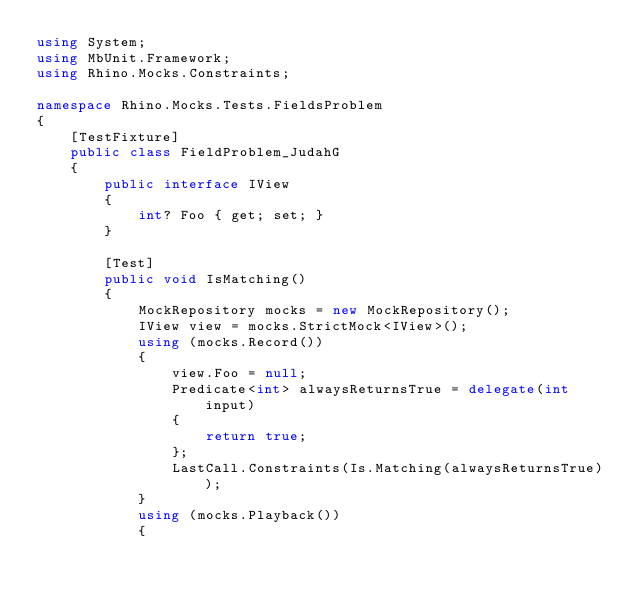<code> <loc_0><loc_0><loc_500><loc_500><_C#_>using System;
using MbUnit.Framework;
using Rhino.Mocks.Constraints;

namespace Rhino.Mocks.Tests.FieldsProblem
{
	[TestFixture]
	public class FieldProblem_JudahG
	{
		public interface IView
		{
			int? Foo { get; set; }
		}

		[Test]
		public void IsMatching()
		{
			MockRepository mocks = new MockRepository();
			IView view = mocks.StrictMock<IView>();
			using (mocks.Record())
			{
				view.Foo = null;
				Predicate<int> alwaysReturnsTrue = delegate(int input)
				{
					return true;
				};
				LastCall.Constraints(Is.Matching(alwaysReturnsTrue));
			}
			using (mocks.Playback())
			{</code> 